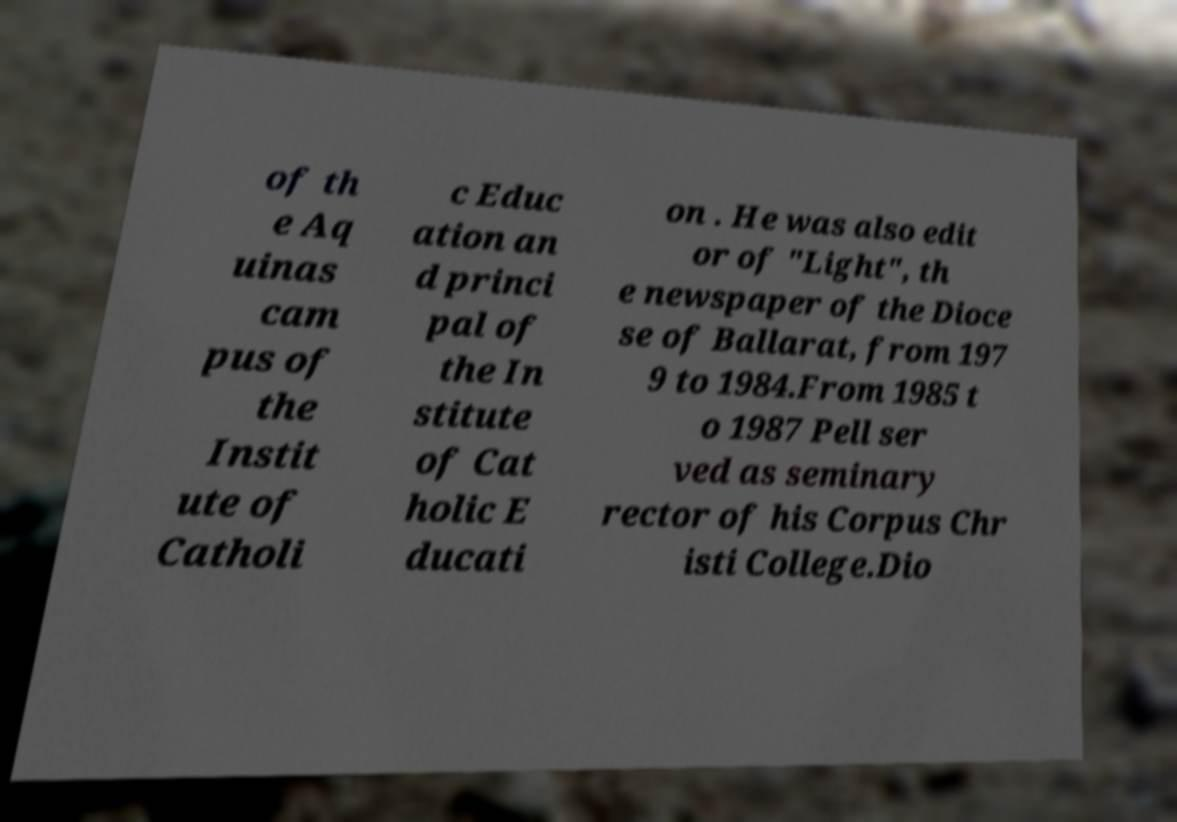Could you assist in decoding the text presented in this image and type it out clearly? of th e Aq uinas cam pus of the Instit ute of Catholi c Educ ation an d princi pal of the In stitute of Cat holic E ducati on . He was also edit or of "Light", th e newspaper of the Dioce se of Ballarat, from 197 9 to 1984.From 1985 t o 1987 Pell ser ved as seminary rector of his Corpus Chr isti College.Dio 